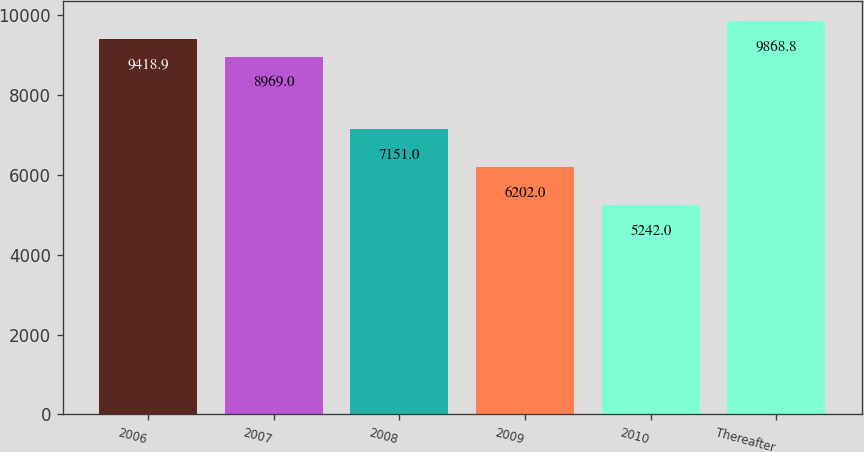<chart> <loc_0><loc_0><loc_500><loc_500><bar_chart><fcel>2006<fcel>2007<fcel>2008<fcel>2009<fcel>2010<fcel>Thereafter<nl><fcel>9418.9<fcel>8969<fcel>7151<fcel>6202<fcel>5242<fcel>9868.8<nl></chart> 